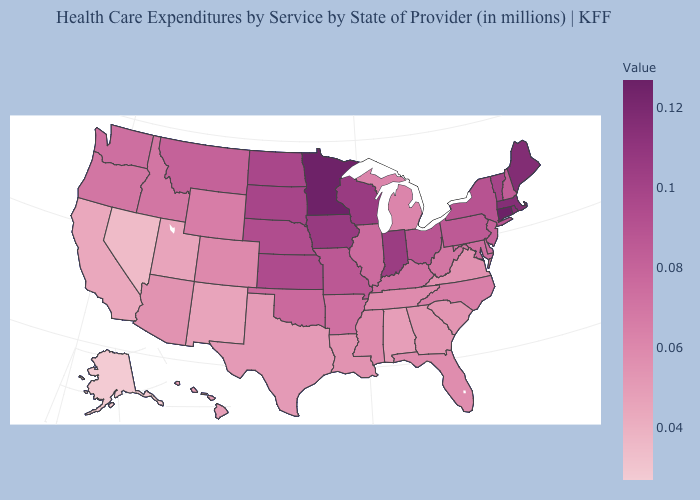Among the states that border North Dakota , which have the highest value?
Write a very short answer. Minnesota. Which states have the lowest value in the USA?
Keep it brief. Alaska. Does Wisconsin have the lowest value in the USA?
Quick response, please. No. Does Georgia have the lowest value in the South?
Quick response, please. No. Among the states that border Utah , does Nevada have the lowest value?
Quick response, please. Yes. Among the states that border New Jersey , does Delaware have the lowest value?
Be succinct. Yes. 